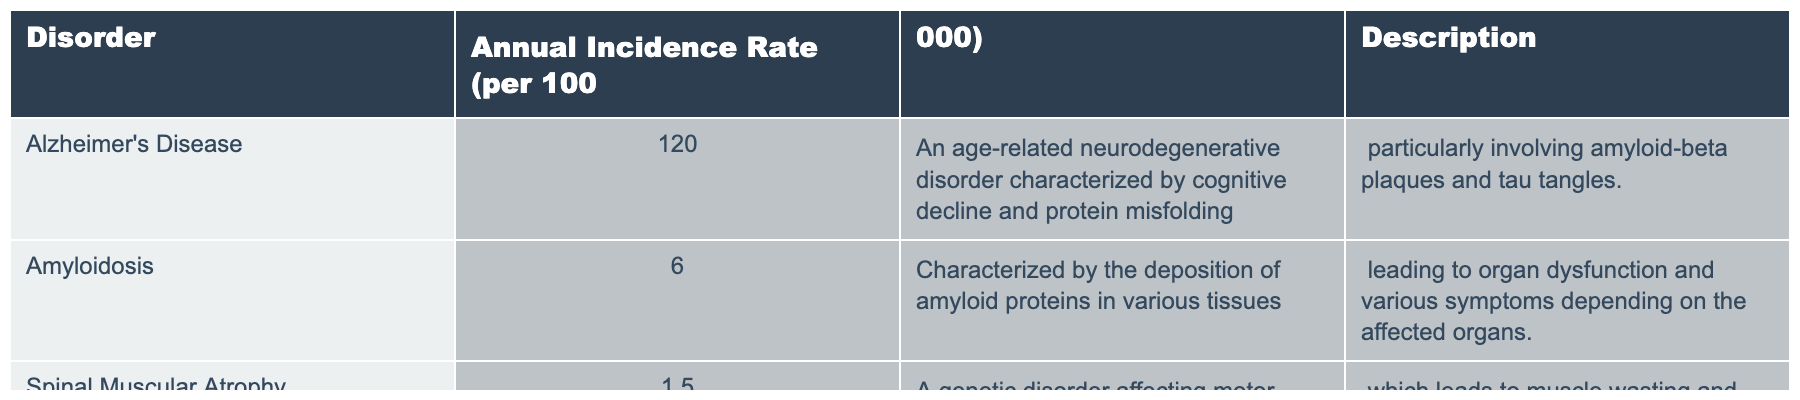What is the annual incidence rate of Alzheimer's Disease? The table lists the annual incidence rate of Alzheimer's Disease as 120 per 100,000 people.
Answer: 120 Which disorder has the lowest annual incidence rate? From the table, Spinal Muscular Atrophy has the lowest annual incidence rate listed as 1.5 per 100,000.
Answer: Spinal Muscular Atrophy What is the combined annual incidence rate for Alzheimer's Disease and Amyloidosis? To find the combined annual incidence rate, we add the rates: 120 (Alzheimer's Disease) + 6 (Amyloidosis) = 126 per 100,000.
Answer: 126 Is it true that Amyloidosis has a higher incidence rate than Spinal Muscular Atrophy? Comparing the rates from the table, Amyloidosis has an incidence rate of 6, and Spinal Muscular Atrophy has 1.5, which confirms that Amyloidosis has a higher incidence rate.
Answer: Yes If we consider just the neurodegenerative disorders listed, what is the average incidence rate? There are two neurodegenerative disorders: Alzheimer's Disease (120) and Amyloidosis (6). The average is (120 + 6) / 2 = 63 per 100,000.
Answer: 63 What is the difference in annual incidence rates between Alzheimer's Disease and Spinal Muscular Atrophy? The annual incidence rate for Alzheimer's Disease is 120, and for Spinal Muscular Atrophy, it is 1.5. The difference is 120 - 1.5 = 118.5.
Answer: 118.5 How many disorders listed have an incidence rate of less than 10 per 100,000? From the data, only Amyloidosis (6) and Spinal Muscular Atrophy (1.5) have an incidence rate less than 10 per 100,000, totaling 2 disorders.
Answer: 2 What is the total annual incidence rate of all three disorders combined? The total is calculated by adding all incidence rates: 120 + 6 + 1.5 = 127.5 per 100,000.
Answer: 127.5 Is the incidence rate of Amyloidosis greater than or equal to 5 per 100,000? The incidence rate of Amyloidosis is 6 per 100,000, which is greater than 5.
Answer: Yes Which disorder has the highest annual incidence rate, and what is that rate? Analyzing the table, Alzheimer's Disease has the highest annual incidence rate at 120 per 100,000.
Answer: Alzheimer's Disease, 120 